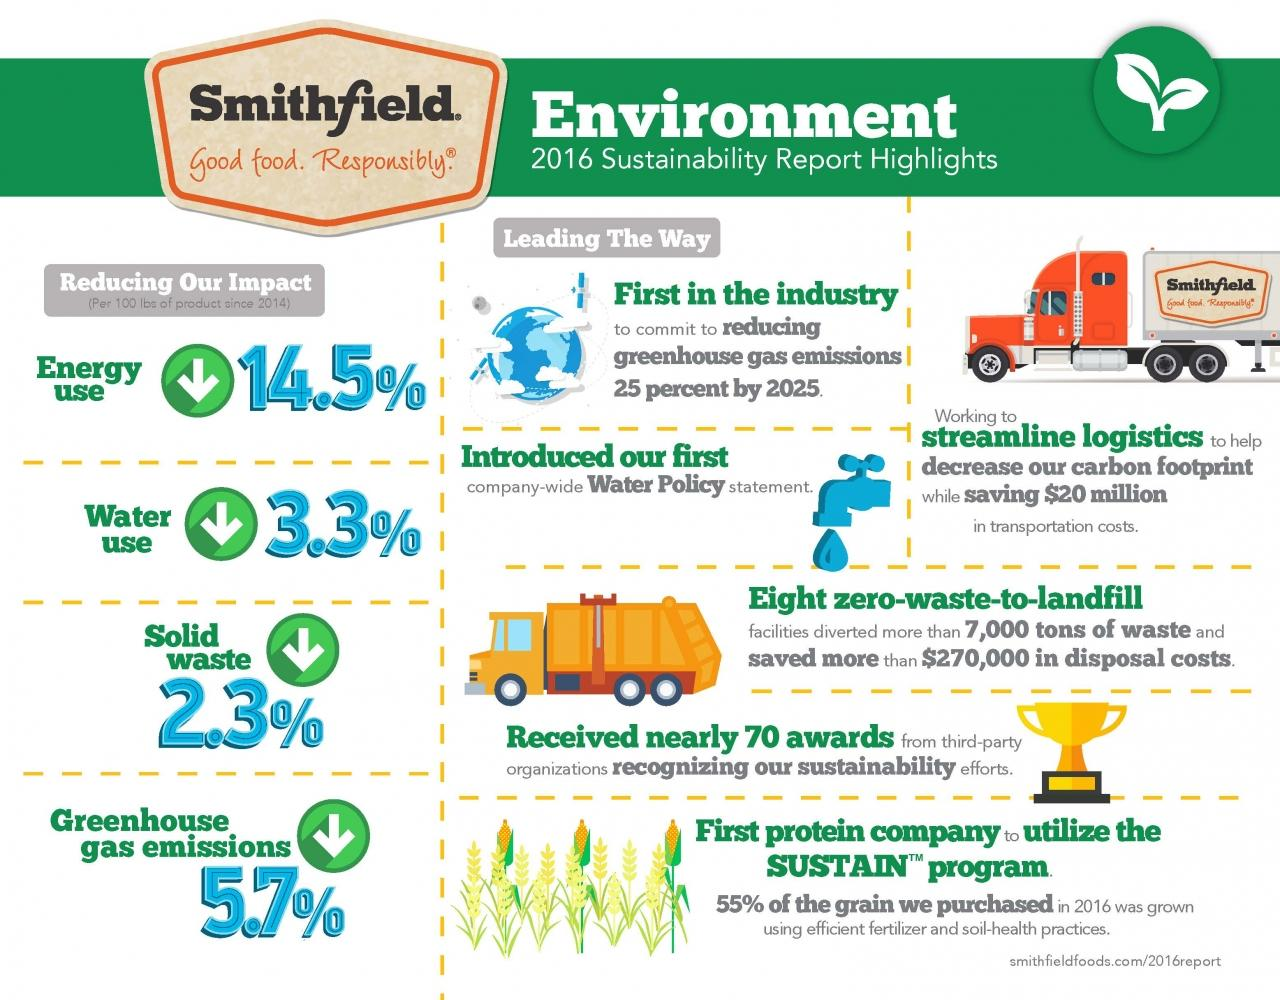List a handful of essential elements in this visual. Smithfield is committed to reducing its energy use and water use by 17.8%. It is estimated that 2 to 3 trucks are shown. 